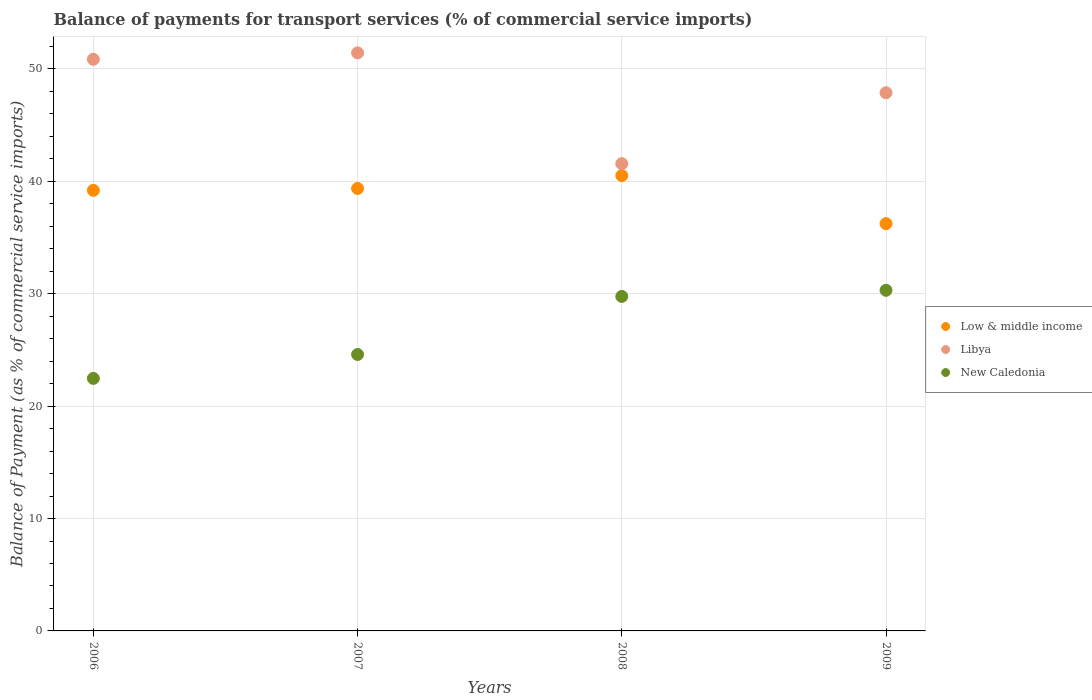What is the balance of payments for transport services in New Caledonia in 2007?
Your response must be concise. 24.6. Across all years, what is the maximum balance of payments for transport services in Low & middle income?
Offer a very short reply. 40.52. Across all years, what is the minimum balance of payments for transport services in Low & middle income?
Keep it short and to the point. 36.24. In which year was the balance of payments for transport services in New Caledonia maximum?
Your response must be concise. 2009. What is the total balance of payments for transport services in Libya in the graph?
Offer a terse response. 191.76. What is the difference between the balance of payments for transport services in Libya in 2007 and that in 2008?
Ensure brevity in your answer.  9.86. What is the difference between the balance of payments for transport services in Libya in 2007 and the balance of payments for transport services in New Caledonia in 2008?
Your answer should be compact. 21.67. What is the average balance of payments for transport services in Low & middle income per year?
Keep it short and to the point. 38.83. In the year 2006, what is the difference between the balance of payments for transport services in Low & middle income and balance of payments for transport services in New Caledonia?
Offer a terse response. 16.73. What is the ratio of the balance of payments for transport services in Libya in 2007 to that in 2008?
Ensure brevity in your answer.  1.24. Is the balance of payments for transport services in Libya in 2007 less than that in 2009?
Your response must be concise. No. What is the difference between the highest and the second highest balance of payments for transport services in New Caledonia?
Give a very brief answer. 0.55. What is the difference between the highest and the lowest balance of payments for transport services in New Caledonia?
Keep it short and to the point. 7.84. In how many years, is the balance of payments for transport services in Low & middle income greater than the average balance of payments for transport services in Low & middle income taken over all years?
Provide a short and direct response. 3. Does the balance of payments for transport services in Low & middle income monotonically increase over the years?
Provide a short and direct response. No. Is the balance of payments for transport services in New Caledonia strictly greater than the balance of payments for transport services in Libya over the years?
Ensure brevity in your answer.  No. What is the difference between two consecutive major ticks on the Y-axis?
Provide a short and direct response. 10. Are the values on the major ticks of Y-axis written in scientific E-notation?
Provide a succinct answer. No. Does the graph contain any zero values?
Ensure brevity in your answer.  No. Where does the legend appear in the graph?
Make the answer very short. Center right. How are the legend labels stacked?
Provide a succinct answer. Vertical. What is the title of the graph?
Your answer should be very brief. Balance of payments for transport services (% of commercial service imports). Does "Tajikistan" appear as one of the legend labels in the graph?
Offer a very short reply. No. What is the label or title of the Y-axis?
Give a very brief answer. Balance of Payment (as % of commercial service imports). What is the Balance of Payment (as % of commercial service imports) in Low & middle income in 2006?
Your answer should be compact. 39.2. What is the Balance of Payment (as % of commercial service imports) of Libya in 2006?
Provide a succinct answer. 50.86. What is the Balance of Payment (as % of commercial service imports) of New Caledonia in 2006?
Your response must be concise. 22.47. What is the Balance of Payment (as % of commercial service imports) of Low & middle income in 2007?
Ensure brevity in your answer.  39.37. What is the Balance of Payment (as % of commercial service imports) of Libya in 2007?
Give a very brief answer. 51.44. What is the Balance of Payment (as % of commercial service imports) in New Caledonia in 2007?
Offer a terse response. 24.6. What is the Balance of Payment (as % of commercial service imports) in Low & middle income in 2008?
Give a very brief answer. 40.52. What is the Balance of Payment (as % of commercial service imports) in Libya in 2008?
Keep it short and to the point. 41.58. What is the Balance of Payment (as % of commercial service imports) of New Caledonia in 2008?
Keep it short and to the point. 29.76. What is the Balance of Payment (as % of commercial service imports) of Low & middle income in 2009?
Your answer should be very brief. 36.24. What is the Balance of Payment (as % of commercial service imports) of Libya in 2009?
Make the answer very short. 47.89. What is the Balance of Payment (as % of commercial service imports) of New Caledonia in 2009?
Offer a terse response. 30.31. Across all years, what is the maximum Balance of Payment (as % of commercial service imports) in Low & middle income?
Provide a succinct answer. 40.52. Across all years, what is the maximum Balance of Payment (as % of commercial service imports) in Libya?
Your answer should be very brief. 51.44. Across all years, what is the maximum Balance of Payment (as % of commercial service imports) of New Caledonia?
Give a very brief answer. 30.31. Across all years, what is the minimum Balance of Payment (as % of commercial service imports) of Low & middle income?
Your answer should be very brief. 36.24. Across all years, what is the minimum Balance of Payment (as % of commercial service imports) in Libya?
Offer a very short reply. 41.58. Across all years, what is the minimum Balance of Payment (as % of commercial service imports) of New Caledonia?
Ensure brevity in your answer.  22.47. What is the total Balance of Payment (as % of commercial service imports) in Low & middle income in the graph?
Offer a very short reply. 155.33. What is the total Balance of Payment (as % of commercial service imports) in Libya in the graph?
Your answer should be compact. 191.76. What is the total Balance of Payment (as % of commercial service imports) of New Caledonia in the graph?
Your answer should be very brief. 107.14. What is the difference between the Balance of Payment (as % of commercial service imports) in Low & middle income in 2006 and that in 2007?
Provide a short and direct response. -0.17. What is the difference between the Balance of Payment (as % of commercial service imports) of Libya in 2006 and that in 2007?
Offer a very short reply. -0.57. What is the difference between the Balance of Payment (as % of commercial service imports) of New Caledonia in 2006 and that in 2007?
Provide a short and direct response. -2.13. What is the difference between the Balance of Payment (as % of commercial service imports) of Low & middle income in 2006 and that in 2008?
Ensure brevity in your answer.  -1.31. What is the difference between the Balance of Payment (as % of commercial service imports) of Libya in 2006 and that in 2008?
Provide a short and direct response. 9.28. What is the difference between the Balance of Payment (as % of commercial service imports) of New Caledonia in 2006 and that in 2008?
Make the answer very short. -7.29. What is the difference between the Balance of Payment (as % of commercial service imports) of Low & middle income in 2006 and that in 2009?
Ensure brevity in your answer.  2.96. What is the difference between the Balance of Payment (as % of commercial service imports) in Libya in 2006 and that in 2009?
Provide a succinct answer. 2.97. What is the difference between the Balance of Payment (as % of commercial service imports) of New Caledonia in 2006 and that in 2009?
Provide a short and direct response. -7.84. What is the difference between the Balance of Payment (as % of commercial service imports) in Low & middle income in 2007 and that in 2008?
Your answer should be compact. -1.15. What is the difference between the Balance of Payment (as % of commercial service imports) in Libya in 2007 and that in 2008?
Provide a short and direct response. 9.86. What is the difference between the Balance of Payment (as % of commercial service imports) of New Caledonia in 2007 and that in 2008?
Provide a succinct answer. -5.16. What is the difference between the Balance of Payment (as % of commercial service imports) in Low & middle income in 2007 and that in 2009?
Offer a very short reply. 3.13. What is the difference between the Balance of Payment (as % of commercial service imports) in Libya in 2007 and that in 2009?
Keep it short and to the point. 3.55. What is the difference between the Balance of Payment (as % of commercial service imports) in New Caledonia in 2007 and that in 2009?
Give a very brief answer. -5.71. What is the difference between the Balance of Payment (as % of commercial service imports) of Low & middle income in 2008 and that in 2009?
Make the answer very short. 4.27. What is the difference between the Balance of Payment (as % of commercial service imports) of Libya in 2008 and that in 2009?
Offer a terse response. -6.31. What is the difference between the Balance of Payment (as % of commercial service imports) in New Caledonia in 2008 and that in 2009?
Provide a short and direct response. -0.55. What is the difference between the Balance of Payment (as % of commercial service imports) in Low & middle income in 2006 and the Balance of Payment (as % of commercial service imports) in Libya in 2007?
Keep it short and to the point. -12.23. What is the difference between the Balance of Payment (as % of commercial service imports) of Low & middle income in 2006 and the Balance of Payment (as % of commercial service imports) of New Caledonia in 2007?
Give a very brief answer. 14.6. What is the difference between the Balance of Payment (as % of commercial service imports) of Libya in 2006 and the Balance of Payment (as % of commercial service imports) of New Caledonia in 2007?
Offer a terse response. 26.26. What is the difference between the Balance of Payment (as % of commercial service imports) in Low & middle income in 2006 and the Balance of Payment (as % of commercial service imports) in Libya in 2008?
Provide a short and direct response. -2.37. What is the difference between the Balance of Payment (as % of commercial service imports) in Low & middle income in 2006 and the Balance of Payment (as % of commercial service imports) in New Caledonia in 2008?
Make the answer very short. 9.44. What is the difference between the Balance of Payment (as % of commercial service imports) of Libya in 2006 and the Balance of Payment (as % of commercial service imports) of New Caledonia in 2008?
Keep it short and to the point. 21.1. What is the difference between the Balance of Payment (as % of commercial service imports) in Low & middle income in 2006 and the Balance of Payment (as % of commercial service imports) in Libya in 2009?
Give a very brief answer. -8.69. What is the difference between the Balance of Payment (as % of commercial service imports) in Low & middle income in 2006 and the Balance of Payment (as % of commercial service imports) in New Caledonia in 2009?
Make the answer very short. 8.89. What is the difference between the Balance of Payment (as % of commercial service imports) of Libya in 2006 and the Balance of Payment (as % of commercial service imports) of New Caledonia in 2009?
Make the answer very short. 20.55. What is the difference between the Balance of Payment (as % of commercial service imports) of Low & middle income in 2007 and the Balance of Payment (as % of commercial service imports) of Libya in 2008?
Give a very brief answer. -2.21. What is the difference between the Balance of Payment (as % of commercial service imports) of Low & middle income in 2007 and the Balance of Payment (as % of commercial service imports) of New Caledonia in 2008?
Your answer should be compact. 9.61. What is the difference between the Balance of Payment (as % of commercial service imports) in Libya in 2007 and the Balance of Payment (as % of commercial service imports) in New Caledonia in 2008?
Offer a terse response. 21.67. What is the difference between the Balance of Payment (as % of commercial service imports) of Low & middle income in 2007 and the Balance of Payment (as % of commercial service imports) of Libya in 2009?
Keep it short and to the point. -8.52. What is the difference between the Balance of Payment (as % of commercial service imports) in Low & middle income in 2007 and the Balance of Payment (as % of commercial service imports) in New Caledonia in 2009?
Your response must be concise. 9.06. What is the difference between the Balance of Payment (as % of commercial service imports) in Libya in 2007 and the Balance of Payment (as % of commercial service imports) in New Caledonia in 2009?
Offer a very short reply. 21.13. What is the difference between the Balance of Payment (as % of commercial service imports) of Low & middle income in 2008 and the Balance of Payment (as % of commercial service imports) of Libya in 2009?
Offer a terse response. -7.37. What is the difference between the Balance of Payment (as % of commercial service imports) in Low & middle income in 2008 and the Balance of Payment (as % of commercial service imports) in New Caledonia in 2009?
Make the answer very short. 10.21. What is the difference between the Balance of Payment (as % of commercial service imports) in Libya in 2008 and the Balance of Payment (as % of commercial service imports) in New Caledonia in 2009?
Give a very brief answer. 11.27. What is the average Balance of Payment (as % of commercial service imports) in Low & middle income per year?
Your answer should be very brief. 38.83. What is the average Balance of Payment (as % of commercial service imports) of Libya per year?
Give a very brief answer. 47.94. What is the average Balance of Payment (as % of commercial service imports) in New Caledonia per year?
Your answer should be compact. 26.78. In the year 2006, what is the difference between the Balance of Payment (as % of commercial service imports) of Low & middle income and Balance of Payment (as % of commercial service imports) of Libya?
Your response must be concise. -11.66. In the year 2006, what is the difference between the Balance of Payment (as % of commercial service imports) of Low & middle income and Balance of Payment (as % of commercial service imports) of New Caledonia?
Make the answer very short. 16.73. In the year 2006, what is the difference between the Balance of Payment (as % of commercial service imports) in Libya and Balance of Payment (as % of commercial service imports) in New Caledonia?
Keep it short and to the point. 28.39. In the year 2007, what is the difference between the Balance of Payment (as % of commercial service imports) in Low & middle income and Balance of Payment (as % of commercial service imports) in Libya?
Give a very brief answer. -12.07. In the year 2007, what is the difference between the Balance of Payment (as % of commercial service imports) in Low & middle income and Balance of Payment (as % of commercial service imports) in New Caledonia?
Keep it short and to the point. 14.77. In the year 2007, what is the difference between the Balance of Payment (as % of commercial service imports) of Libya and Balance of Payment (as % of commercial service imports) of New Caledonia?
Your answer should be very brief. 26.84. In the year 2008, what is the difference between the Balance of Payment (as % of commercial service imports) in Low & middle income and Balance of Payment (as % of commercial service imports) in Libya?
Your answer should be very brief. -1.06. In the year 2008, what is the difference between the Balance of Payment (as % of commercial service imports) of Low & middle income and Balance of Payment (as % of commercial service imports) of New Caledonia?
Your answer should be compact. 10.76. In the year 2008, what is the difference between the Balance of Payment (as % of commercial service imports) in Libya and Balance of Payment (as % of commercial service imports) in New Caledonia?
Give a very brief answer. 11.81. In the year 2009, what is the difference between the Balance of Payment (as % of commercial service imports) in Low & middle income and Balance of Payment (as % of commercial service imports) in Libya?
Give a very brief answer. -11.65. In the year 2009, what is the difference between the Balance of Payment (as % of commercial service imports) in Low & middle income and Balance of Payment (as % of commercial service imports) in New Caledonia?
Your answer should be compact. 5.93. In the year 2009, what is the difference between the Balance of Payment (as % of commercial service imports) in Libya and Balance of Payment (as % of commercial service imports) in New Caledonia?
Keep it short and to the point. 17.58. What is the ratio of the Balance of Payment (as % of commercial service imports) of Low & middle income in 2006 to that in 2007?
Offer a very short reply. 1. What is the ratio of the Balance of Payment (as % of commercial service imports) of Libya in 2006 to that in 2007?
Your answer should be compact. 0.99. What is the ratio of the Balance of Payment (as % of commercial service imports) of New Caledonia in 2006 to that in 2007?
Offer a terse response. 0.91. What is the ratio of the Balance of Payment (as % of commercial service imports) in Low & middle income in 2006 to that in 2008?
Make the answer very short. 0.97. What is the ratio of the Balance of Payment (as % of commercial service imports) of Libya in 2006 to that in 2008?
Give a very brief answer. 1.22. What is the ratio of the Balance of Payment (as % of commercial service imports) in New Caledonia in 2006 to that in 2008?
Provide a succinct answer. 0.75. What is the ratio of the Balance of Payment (as % of commercial service imports) in Low & middle income in 2006 to that in 2009?
Ensure brevity in your answer.  1.08. What is the ratio of the Balance of Payment (as % of commercial service imports) in Libya in 2006 to that in 2009?
Give a very brief answer. 1.06. What is the ratio of the Balance of Payment (as % of commercial service imports) in New Caledonia in 2006 to that in 2009?
Your answer should be very brief. 0.74. What is the ratio of the Balance of Payment (as % of commercial service imports) in Low & middle income in 2007 to that in 2008?
Make the answer very short. 0.97. What is the ratio of the Balance of Payment (as % of commercial service imports) in Libya in 2007 to that in 2008?
Make the answer very short. 1.24. What is the ratio of the Balance of Payment (as % of commercial service imports) of New Caledonia in 2007 to that in 2008?
Your answer should be compact. 0.83. What is the ratio of the Balance of Payment (as % of commercial service imports) in Low & middle income in 2007 to that in 2009?
Offer a very short reply. 1.09. What is the ratio of the Balance of Payment (as % of commercial service imports) in Libya in 2007 to that in 2009?
Your answer should be very brief. 1.07. What is the ratio of the Balance of Payment (as % of commercial service imports) in New Caledonia in 2007 to that in 2009?
Give a very brief answer. 0.81. What is the ratio of the Balance of Payment (as % of commercial service imports) of Low & middle income in 2008 to that in 2009?
Your answer should be compact. 1.12. What is the ratio of the Balance of Payment (as % of commercial service imports) in Libya in 2008 to that in 2009?
Your response must be concise. 0.87. What is the ratio of the Balance of Payment (as % of commercial service imports) of New Caledonia in 2008 to that in 2009?
Give a very brief answer. 0.98. What is the difference between the highest and the second highest Balance of Payment (as % of commercial service imports) of Low & middle income?
Ensure brevity in your answer.  1.15. What is the difference between the highest and the second highest Balance of Payment (as % of commercial service imports) of Libya?
Keep it short and to the point. 0.57. What is the difference between the highest and the second highest Balance of Payment (as % of commercial service imports) of New Caledonia?
Make the answer very short. 0.55. What is the difference between the highest and the lowest Balance of Payment (as % of commercial service imports) in Low & middle income?
Your answer should be very brief. 4.27. What is the difference between the highest and the lowest Balance of Payment (as % of commercial service imports) in Libya?
Your answer should be compact. 9.86. What is the difference between the highest and the lowest Balance of Payment (as % of commercial service imports) in New Caledonia?
Provide a short and direct response. 7.84. 